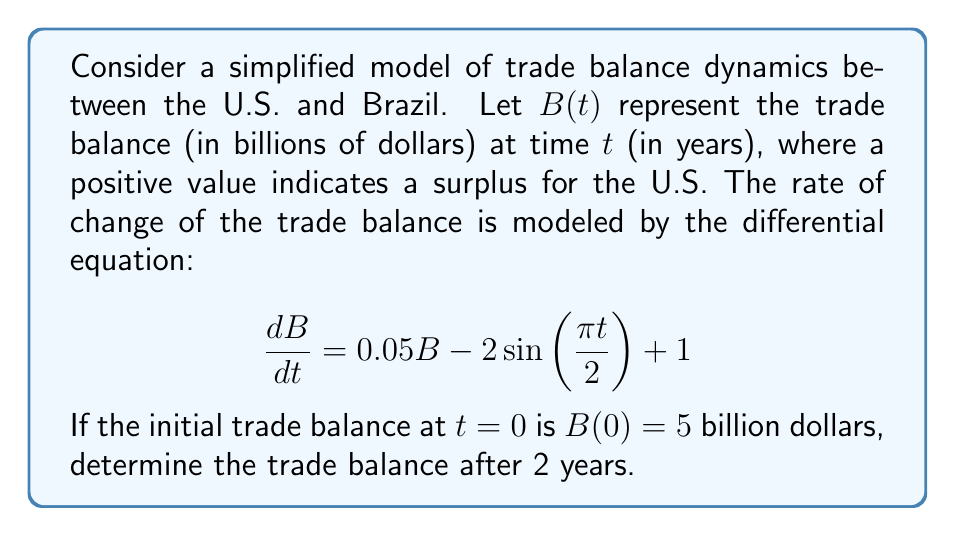What is the answer to this math problem? To solve this first-order linear differential equation, we'll use the integrating factor method:

1) The equation is in the form $\frac{dB}{dt} + P(t)B = Q(t)$, where:
   $P(t) = -0.05$ and $Q(t) = -2\sin(\frac{\pi t}{2}) + 1$

2) The integrating factor is $\mu(t) = e^{\int P(t) dt} = e^{-0.05t}$

3) Multiply both sides of the equation by $\mu(t)$:
   $e^{-0.05t}\frac{dB}{dt} + 0.05e^{-0.05t}B = e^{-0.05t}(-2\sin(\frac{\pi t}{2}) + 1)$

4) The left side is now the derivative of $e^{-0.05t}B$. Integrate both sides:
   $e^{-0.05t}B = \int e^{-0.05t}(-2\sin(\frac{\pi t}{2}) + 1) dt + C$

5) Evaluate the integral:
   $e^{-0.05t}B = \frac{4\pi e^{-0.05t}}{(0.05^2 + (\frac{\pi}{2})^2)}(\frac{\pi}{2}\cos(\frac{\pi t}{2}) + 0.05\sin(\frac{\pi t}{2})) - \frac{20e^{-0.05t}}{0.05} + C$

6) Solve for $B$:
   $B = \frac{4\pi}{(0.05^2 + (\frac{\pi}{2})^2)}(\frac{\pi}{2}\cos(\frac{\pi t}{2}) + 0.05\sin(\frac{\pi t}{2})) - 20 + Ce^{0.05t}$

7) Use the initial condition $B(0) = 5$ to find $C$:
   $5 = \frac{2\pi^2}{(0.05^2 + (\frac{\pi}{2})^2)} - 20 + C$
   $C = 25 - \frac{2\pi^2}{(0.05^2 + (\frac{\pi}{2})^2)}$

8) Substitute $t=2$ into the solution:
   $B(2) = \frac{4\pi}{(0.05^2 + (\frac{\pi}{2})^2)}(-\frac{\pi}{2}\cos(\pi) + 0.05\sin(\pi)) - 20 + (25 - \frac{2\pi^2}{(0.05^2 + (\frac{\pi}{2})^2)})e^{0.1}$

9) Simplify and calculate the final value.
Answer: The trade balance after 2 years is approximately $10.76$ billion dollars. 